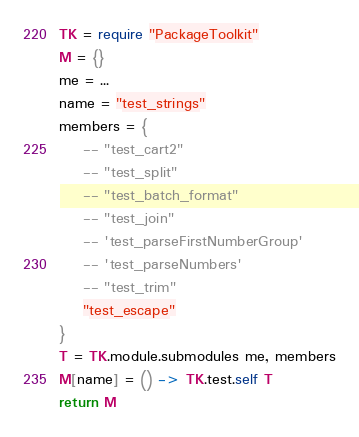Convert code to text. <code><loc_0><loc_0><loc_500><loc_500><_MoonScript_>TK = require "PackageToolkit"
M = {}
me = ...
name = "test_strings"
members = {
    -- "test_cart2"
    -- "test_split"
    -- "test_batch_format"
    -- "test_join"
    -- 'test_parseFirstNumberGroup'
    -- 'test_parseNumbers'
    -- "test_trim"
    "test_escape"
}
T = TK.module.submodules me, members
M[name] = () -> TK.test.self T
return M</code> 